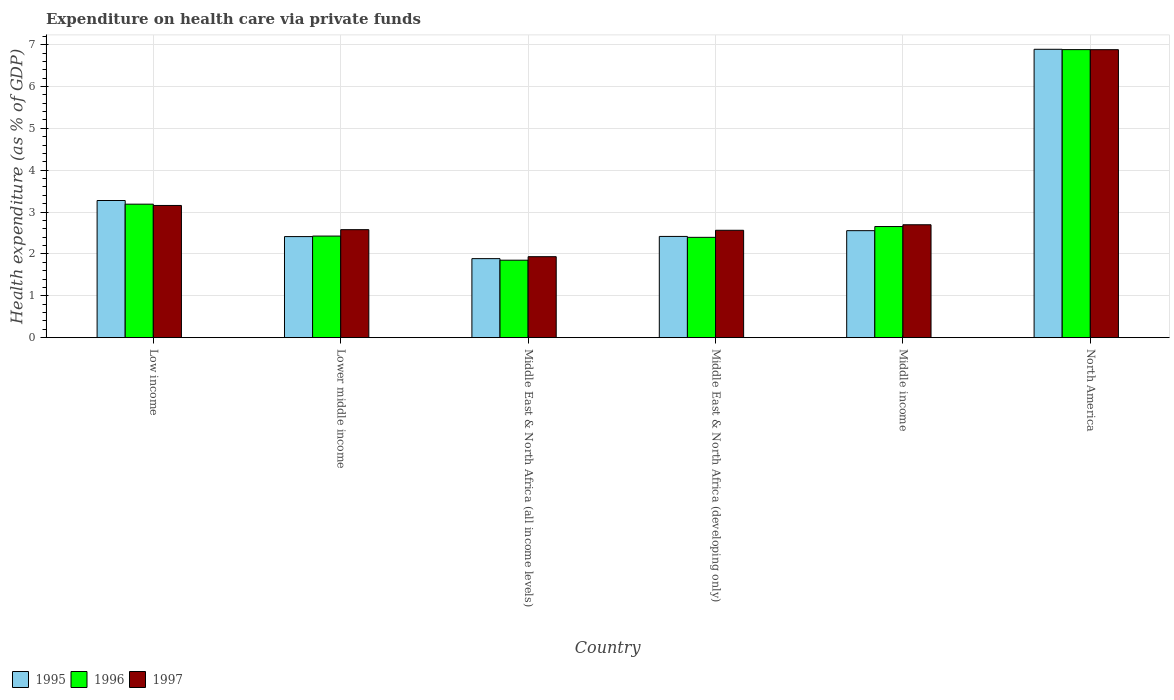Are the number of bars per tick equal to the number of legend labels?
Ensure brevity in your answer.  Yes. Are the number of bars on each tick of the X-axis equal?
Keep it short and to the point. Yes. How many bars are there on the 3rd tick from the right?
Your answer should be very brief. 3. What is the expenditure made on health care in 1996 in Middle East & North Africa (developing only)?
Ensure brevity in your answer.  2.4. Across all countries, what is the maximum expenditure made on health care in 1995?
Ensure brevity in your answer.  6.89. Across all countries, what is the minimum expenditure made on health care in 1996?
Provide a short and direct response. 1.85. In which country was the expenditure made on health care in 1997 maximum?
Provide a short and direct response. North America. In which country was the expenditure made on health care in 1995 minimum?
Your answer should be compact. Middle East & North Africa (all income levels). What is the total expenditure made on health care in 1996 in the graph?
Your response must be concise. 19.4. What is the difference between the expenditure made on health care in 1995 in Low income and that in Lower middle income?
Your answer should be very brief. 0.86. What is the difference between the expenditure made on health care in 1996 in North America and the expenditure made on health care in 1995 in Middle East & North Africa (all income levels)?
Ensure brevity in your answer.  4.99. What is the average expenditure made on health care in 1996 per country?
Your response must be concise. 3.23. What is the difference between the expenditure made on health care of/in 1996 and expenditure made on health care of/in 1995 in North America?
Your response must be concise. -0.01. What is the ratio of the expenditure made on health care in 1995 in Low income to that in North America?
Make the answer very short. 0.48. Is the expenditure made on health care in 1996 in Lower middle income less than that in North America?
Make the answer very short. Yes. What is the difference between the highest and the second highest expenditure made on health care in 1997?
Ensure brevity in your answer.  -0.46. What is the difference between the highest and the lowest expenditure made on health care in 1997?
Make the answer very short. 4.95. Is the sum of the expenditure made on health care in 1995 in Middle East & North Africa (all income levels) and Middle East & North Africa (developing only) greater than the maximum expenditure made on health care in 1996 across all countries?
Make the answer very short. No. What does the 2nd bar from the left in North America represents?
Your answer should be compact. 1996. What does the 3rd bar from the right in Middle income represents?
Make the answer very short. 1995. How many bars are there?
Offer a very short reply. 18. Are all the bars in the graph horizontal?
Offer a very short reply. No. How many countries are there in the graph?
Your answer should be very brief. 6. What is the difference between two consecutive major ticks on the Y-axis?
Your response must be concise. 1. What is the title of the graph?
Provide a short and direct response. Expenditure on health care via private funds. What is the label or title of the Y-axis?
Keep it short and to the point. Health expenditure (as % of GDP). What is the Health expenditure (as % of GDP) in 1995 in Low income?
Your answer should be compact. 3.28. What is the Health expenditure (as % of GDP) in 1996 in Low income?
Provide a short and direct response. 3.19. What is the Health expenditure (as % of GDP) of 1997 in Low income?
Provide a short and direct response. 3.16. What is the Health expenditure (as % of GDP) in 1995 in Lower middle income?
Keep it short and to the point. 2.41. What is the Health expenditure (as % of GDP) in 1996 in Lower middle income?
Offer a very short reply. 2.43. What is the Health expenditure (as % of GDP) of 1997 in Lower middle income?
Ensure brevity in your answer.  2.58. What is the Health expenditure (as % of GDP) in 1995 in Middle East & North Africa (all income levels)?
Offer a terse response. 1.89. What is the Health expenditure (as % of GDP) in 1996 in Middle East & North Africa (all income levels)?
Offer a very short reply. 1.85. What is the Health expenditure (as % of GDP) of 1997 in Middle East & North Africa (all income levels)?
Your answer should be compact. 1.93. What is the Health expenditure (as % of GDP) in 1995 in Middle East & North Africa (developing only)?
Provide a short and direct response. 2.42. What is the Health expenditure (as % of GDP) in 1996 in Middle East & North Africa (developing only)?
Make the answer very short. 2.4. What is the Health expenditure (as % of GDP) of 1997 in Middle East & North Africa (developing only)?
Your answer should be compact. 2.57. What is the Health expenditure (as % of GDP) in 1995 in Middle income?
Offer a very short reply. 2.56. What is the Health expenditure (as % of GDP) in 1996 in Middle income?
Your answer should be very brief. 2.65. What is the Health expenditure (as % of GDP) in 1997 in Middle income?
Your answer should be compact. 2.7. What is the Health expenditure (as % of GDP) in 1995 in North America?
Offer a very short reply. 6.89. What is the Health expenditure (as % of GDP) of 1996 in North America?
Your answer should be very brief. 6.88. What is the Health expenditure (as % of GDP) of 1997 in North America?
Ensure brevity in your answer.  6.88. Across all countries, what is the maximum Health expenditure (as % of GDP) of 1995?
Provide a short and direct response. 6.89. Across all countries, what is the maximum Health expenditure (as % of GDP) of 1996?
Offer a very short reply. 6.88. Across all countries, what is the maximum Health expenditure (as % of GDP) in 1997?
Ensure brevity in your answer.  6.88. Across all countries, what is the minimum Health expenditure (as % of GDP) in 1995?
Keep it short and to the point. 1.89. Across all countries, what is the minimum Health expenditure (as % of GDP) of 1996?
Make the answer very short. 1.85. Across all countries, what is the minimum Health expenditure (as % of GDP) in 1997?
Keep it short and to the point. 1.93. What is the total Health expenditure (as % of GDP) of 1995 in the graph?
Your answer should be compact. 19.44. What is the total Health expenditure (as % of GDP) of 1996 in the graph?
Your answer should be very brief. 19.4. What is the total Health expenditure (as % of GDP) of 1997 in the graph?
Make the answer very short. 19.81. What is the difference between the Health expenditure (as % of GDP) in 1995 in Low income and that in Lower middle income?
Your answer should be compact. 0.86. What is the difference between the Health expenditure (as % of GDP) of 1996 in Low income and that in Lower middle income?
Your answer should be very brief. 0.76. What is the difference between the Health expenditure (as % of GDP) in 1997 in Low income and that in Lower middle income?
Your response must be concise. 0.58. What is the difference between the Health expenditure (as % of GDP) in 1995 in Low income and that in Middle East & North Africa (all income levels)?
Your response must be concise. 1.39. What is the difference between the Health expenditure (as % of GDP) of 1996 in Low income and that in Middle East & North Africa (all income levels)?
Offer a terse response. 1.34. What is the difference between the Health expenditure (as % of GDP) of 1997 in Low income and that in Middle East & North Africa (all income levels)?
Your answer should be compact. 1.22. What is the difference between the Health expenditure (as % of GDP) of 1995 in Low income and that in Middle East & North Africa (developing only)?
Make the answer very short. 0.86. What is the difference between the Health expenditure (as % of GDP) in 1996 in Low income and that in Middle East & North Africa (developing only)?
Your answer should be very brief. 0.79. What is the difference between the Health expenditure (as % of GDP) of 1997 in Low income and that in Middle East & North Africa (developing only)?
Your answer should be compact. 0.59. What is the difference between the Health expenditure (as % of GDP) of 1995 in Low income and that in Middle income?
Give a very brief answer. 0.72. What is the difference between the Health expenditure (as % of GDP) in 1996 in Low income and that in Middle income?
Provide a short and direct response. 0.53. What is the difference between the Health expenditure (as % of GDP) in 1997 in Low income and that in Middle income?
Provide a short and direct response. 0.46. What is the difference between the Health expenditure (as % of GDP) in 1995 in Low income and that in North America?
Ensure brevity in your answer.  -3.61. What is the difference between the Health expenditure (as % of GDP) of 1996 in Low income and that in North America?
Keep it short and to the point. -3.69. What is the difference between the Health expenditure (as % of GDP) of 1997 in Low income and that in North America?
Your answer should be compact. -3.72. What is the difference between the Health expenditure (as % of GDP) of 1995 in Lower middle income and that in Middle East & North Africa (all income levels)?
Offer a terse response. 0.53. What is the difference between the Health expenditure (as % of GDP) in 1996 in Lower middle income and that in Middle East & North Africa (all income levels)?
Ensure brevity in your answer.  0.58. What is the difference between the Health expenditure (as % of GDP) in 1997 in Lower middle income and that in Middle East & North Africa (all income levels)?
Offer a terse response. 0.65. What is the difference between the Health expenditure (as % of GDP) in 1995 in Lower middle income and that in Middle East & North Africa (developing only)?
Give a very brief answer. -0. What is the difference between the Health expenditure (as % of GDP) of 1996 in Lower middle income and that in Middle East & North Africa (developing only)?
Ensure brevity in your answer.  0.03. What is the difference between the Health expenditure (as % of GDP) in 1997 in Lower middle income and that in Middle East & North Africa (developing only)?
Provide a short and direct response. 0.01. What is the difference between the Health expenditure (as % of GDP) of 1995 in Lower middle income and that in Middle income?
Ensure brevity in your answer.  -0.14. What is the difference between the Health expenditure (as % of GDP) in 1996 in Lower middle income and that in Middle income?
Your answer should be very brief. -0.23. What is the difference between the Health expenditure (as % of GDP) of 1997 in Lower middle income and that in Middle income?
Ensure brevity in your answer.  -0.12. What is the difference between the Health expenditure (as % of GDP) in 1995 in Lower middle income and that in North America?
Offer a terse response. -4.47. What is the difference between the Health expenditure (as % of GDP) of 1996 in Lower middle income and that in North America?
Offer a very short reply. -4.45. What is the difference between the Health expenditure (as % of GDP) of 1997 in Lower middle income and that in North America?
Make the answer very short. -4.3. What is the difference between the Health expenditure (as % of GDP) of 1995 in Middle East & North Africa (all income levels) and that in Middle East & North Africa (developing only)?
Keep it short and to the point. -0.53. What is the difference between the Health expenditure (as % of GDP) in 1996 in Middle East & North Africa (all income levels) and that in Middle East & North Africa (developing only)?
Your answer should be very brief. -0.55. What is the difference between the Health expenditure (as % of GDP) in 1997 in Middle East & North Africa (all income levels) and that in Middle East & North Africa (developing only)?
Offer a terse response. -0.63. What is the difference between the Health expenditure (as % of GDP) of 1995 in Middle East & North Africa (all income levels) and that in Middle income?
Keep it short and to the point. -0.67. What is the difference between the Health expenditure (as % of GDP) in 1996 in Middle East & North Africa (all income levels) and that in Middle income?
Keep it short and to the point. -0.8. What is the difference between the Health expenditure (as % of GDP) of 1997 in Middle East & North Africa (all income levels) and that in Middle income?
Your response must be concise. -0.76. What is the difference between the Health expenditure (as % of GDP) of 1995 in Middle East & North Africa (all income levels) and that in North America?
Your answer should be compact. -5. What is the difference between the Health expenditure (as % of GDP) in 1996 in Middle East & North Africa (all income levels) and that in North America?
Offer a terse response. -5.03. What is the difference between the Health expenditure (as % of GDP) of 1997 in Middle East & North Africa (all income levels) and that in North America?
Provide a short and direct response. -4.95. What is the difference between the Health expenditure (as % of GDP) in 1995 in Middle East & North Africa (developing only) and that in Middle income?
Offer a terse response. -0.14. What is the difference between the Health expenditure (as % of GDP) in 1996 in Middle East & North Africa (developing only) and that in Middle income?
Your answer should be compact. -0.26. What is the difference between the Health expenditure (as % of GDP) of 1997 in Middle East & North Africa (developing only) and that in Middle income?
Keep it short and to the point. -0.13. What is the difference between the Health expenditure (as % of GDP) of 1995 in Middle East & North Africa (developing only) and that in North America?
Provide a succinct answer. -4.47. What is the difference between the Health expenditure (as % of GDP) in 1996 in Middle East & North Africa (developing only) and that in North America?
Your answer should be compact. -4.48. What is the difference between the Health expenditure (as % of GDP) of 1997 in Middle East & North Africa (developing only) and that in North America?
Make the answer very short. -4.31. What is the difference between the Health expenditure (as % of GDP) of 1995 in Middle income and that in North America?
Your response must be concise. -4.33. What is the difference between the Health expenditure (as % of GDP) of 1996 in Middle income and that in North America?
Give a very brief answer. -4.23. What is the difference between the Health expenditure (as % of GDP) in 1997 in Middle income and that in North America?
Your response must be concise. -4.18. What is the difference between the Health expenditure (as % of GDP) of 1995 in Low income and the Health expenditure (as % of GDP) of 1996 in Lower middle income?
Offer a terse response. 0.85. What is the difference between the Health expenditure (as % of GDP) of 1995 in Low income and the Health expenditure (as % of GDP) of 1997 in Lower middle income?
Offer a terse response. 0.7. What is the difference between the Health expenditure (as % of GDP) in 1996 in Low income and the Health expenditure (as % of GDP) in 1997 in Lower middle income?
Your answer should be compact. 0.61. What is the difference between the Health expenditure (as % of GDP) in 1995 in Low income and the Health expenditure (as % of GDP) in 1996 in Middle East & North Africa (all income levels)?
Your answer should be very brief. 1.43. What is the difference between the Health expenditure (as % of GDP) of 1995 in Low income and the Health expenditure (as % of GDP) of 1997 in Middle East & North Africa (all income levels)?
Keep it short and to the point. 1.34. What is the difference between the Health expenditure (as % of GDP) in 1996 in Low income and the Health expenditure (as % of GDP) in 1997 in Middle East & North Africa (all income levels)?
Provide a succinct answer. 1.25. What is the difference between the Health expenditure (as % of GDP) of 1995 in Low income and the Health expenditure (as % of GDP) of 1996 in Middle East & North Africa (developing only)?
Provide a short and direct response. 0.88. What is the difference between the Health expenditure (as % of GDP) of 1995 in Low income and the Health expenditure (as % of GDP) of 1997 in Middle East & North Africa (developing only)?
Your answer should be compact. 0.71. What is the difference between the Health expenditure (as % of GDP) in 1996 in Low income and the Health expenditure (as % of GDP) in 1997 in Middle East & North Africa (developing only)?
Your answer should be compact. 0.62. What is the difference between the Health expenditure (as % of GDP) in 1995 in Low income and the Health expenditure (as % of GDP) in 1996 in Middle income?
Your response must be concise. 0.62. What is the difference between the Health expenditure (as % of GDP) of 1995 in Low income and the Health expenditure (as % of GDP) of 1997 in Middle income?
Offer a very short reply. 0.58. What is the difference between the Health expenditure (as % of GDP) of 1996 in Low income and the Health expenditure (as % of GDP) of 1997 in Middle income?
Provide a short and direct response. 0.49. What is the difference between the Health expenditure (as % of GDP) in 1995 in Low income and the Health expenditure (as % of GDP) in 1996 in North America?
Ensure brevity in your answer.  -3.6. What is the difference between the Health expenditure (as % of GDP) in 1995 in Low income and the Health expenditure (as % of GDP) in 1997 in North America?
Your answer should be very brief. -3.6. What is the difference between the Health expenditure (as % of GDP) of 1996 in Low income and the Health expenditure (as % of GDP) of 1997 in North America?
Ensure brevity in your answer.  -3.69. What is the difference between the Health expenditure (as % of GDP) in 1995 in Lower middle income and the Health expenditure (as % of GDP) in 1996 in Middle East & North Africa (all income levels)?
Ensure brevity in your answer.  0.56. What is the difference between the Health expenditure (as % of GDP) in 1995 in Lower middle income and the Health expenditure (as % of GDP) in 1997 in Middle East & North Africa (all income levels)?
Offer a terse response. 0.48. What is the difference between the Health expenditure (as % of GDP) of 1996 in Lower middle income and the Health expenditure (as % of GDP) of 1997 in Middle East & North Africa (all income levels)?
Provide a short and direct response. 0.49. What is the difference between the Health expenditure (as % of GDP) of 1995 in Lower middle income and the Health expenditure (as % of GDP) of 1996 in Middle East & North Africa (developing only)?
Offer a terse response. 0.02. What is the difference between the Health expenditure (as % of GDP) of 1995 in Lower middle income and the Health expenditure (as % of GDP) of 1997 in Middle East & North Africa (developing only)?
Your answer should be very brief. -0.15. What is the difference between the Health expenditure (as % of GDP) in 1996 in Lower middle income and the Health expenditure (as % of GDP) in 1997 in Middle East & North Africa (developing only)?
Your answer should be compact. -0.14. What is the difference between the Health expenditure (as % of GDP) of 1995 in Lower middle income and the Health expenditure (as % of GDP) of 1996 in Middle income?
Your answer should be very brief. -0.24. What is the difference between the Health expenditure (as % of GDP) of 1995 in Lower middle income and the Health expenditure (as % of GDP) of 1997 in Middle income?
Your answer should be very brief. -0.28. What is the difference between the Health expenditure (as % of GDP) in 1996 in Lower middle income and the Health expenditure (as % of GDP) in 1997 in Middle income?
Provide a short and direct response. -0.27. What is the difference between the Health expenditure (as % of GDP) in 1995 in Lower middle income and the Health expenditure (as % of GDP) in 1996 in North America?
Make the answer very short. -4.47. What is the difference between the Health expenditure (as % of GDP) in 1995 in Lower middle income and the Health expenditure (as % of GDP) in 1997 in North America?
Give a very brief answer. -4.47. What is the difference between the Health expenditure (as % of GDP) of 1996 in Lower middle income and the Health expenditure (as % of GDP) of 1997 in North America?
Provide a succinct answer. -4.45. What is the difference between the Health expenditure (as % of GDP) of 1995 in Middle East & North Africa (all income levels) and the Health expenditure (as % of GDP) of 1996 in Middle East & North Africa (developing only)?
Your response must be concise. -0.51. What is the difference between the Health expenditure (as % of GDP) in 1995 in Middle East & North Africa (all income levels) and the Health expenditure (as % of GDP) in 1997 in Middle East & North Africa (developing only)?
Provide a succinct answer. -0.68. What is the difference between the Health expenditure (as % of GDP) of 1996 in Middle East & North Africa (all income levels) and the Health expenditure (as % of GDP) of 1997 in Middle East & North Africa (developing only)?
Provide a short and direct response. -0.71. What is the difference between the Health expenditure (as % of GDP) in 1995 in Middle East & North Africa (all income levels) and the Health expenditure (as % of GDP) in 1996 in Middle income?
Keep it short and to the point. -0.77. What is the difference between the Health expenditure (as % of GDP) of 1995 in Middle East & North Africa (all income levels) and the Health expenditure (as % of GDP) of 1997 in Middle income?
Make the answer very short. -0.81. What is the difference between the Health expenditure (as % of GDP) in 1996 in Middle East & North Africa (all income levels) and the Health expenditure (as % of GDP) in 1997 in Middle income?
Offer a terse response. -0.85. What is the difference between the Health expenditure (as % of GDP) of 1995 in Middle East & North Africa (all income levels) and the Health expenditure (as % of GDP) of 1996 in North America?
Your response must be concise. -4.99. What is the difference between the Health expenditure (as % of GDP) of 1995 in Middle East & North Africa (all income levels) and the Health expenditure (as % of GDP) of 1997 in North America?
Your answer should be very brief. -4.99. What is the difference between the Health expenditure (as % of GDP) of 1996 in Middle East & North Africa (all income levels) and the Health expenditure (as % of GDP) of 1997 in North America?
Your response must be concise. -5.03. What is the difference between the Health expenditure (as % of GDP) of 1995 in Middle East & North Africa (developing only) and the Health expenditure (as % of GDP) of 1996 in Middle income?
Offer a very short reply. -0.24. What is the difference between the Health expenditure (as % of GDP) in 1995 in Middle East & North Africa (developing only) and the Health expenditure (as % of GDP) in 1997 in Middle income?
Your answer should be compact. -0.28. What is the difference between the Health expenditure (as % of GDP) in 1996 in Middle East & North Africa (developing only) and the Health expenditure (as % of GDP) in 1997 in Middle income?
Your answer should be compact. -0.3. What is the difference between the Health expenditure (as % of GDP) in 1995 in Middle East & North Africa (developing only) and the Health expenditure (as % of GDP) in 1996 in North America?
Your answer should be very brief. -4.46. What is the difference between the Health expenditure (as % of GDP) in 1995 in Middle East & North Africa (developing only) and the Health expenditure (as % of GDP) in 1997 in North America?
Offer a very short reply. -4.46. What is the difference between the Health expenditure (as % of GDP) in 1996 in Middle East & North Africa (developing only) and the Health expenditure (as % of GDP) in 1997 in North America?
Provide a short and direct response. -4.48. What is the difference between the Health expenditure (as % of GDP) of 1995 in Middle income and the Health expenditure (as % of GDP) of 1996 in North America?
Give a very brief answer. -4.33. What is the difference between the Health expenditure (as % of GDP) of 1995 in Middle income and the Health expenditure (as % of GDP) of 1997 in North America?
Make the answer very short. -4.32. What is the difference between the Health expenditure (as % of GDP) of 1996 in Middle income and the Health expenditure (as % of GDP) of 1997 in North America?
Provide a short and direct response. -4.23. What is the average Health expenditure (as % of GDP) of 1995 per country?
Give a very brief answer. 3.24. What is the average Health expenditure (as % of GDP) of 1996 per country?
Ensure brevity in your answer.  3.23. What is the average Health expenditure (as % of GDP) of 1997 per country?
Ensure brevity in your answer.  3.3. What is the difference between the Health expenditure (as % of GDP) in 1995 and Health expenditure (as % of GDP) in 1996 in Low income?
Ensure brevity in your answer.  0.09. What is the difference between the Health expenditure (as % of GDP) of 1995 and Health expenditure (as % of GDP) of 1997 in Low income?
Your response must be concise. 0.12. What is the difference between the Health expenditure (as % of GDP) in 1996 and Health expenditure (as % of GDP) in 1997 in Low income?
Keep it short and to the point. 0.03. What is the difference between the Health expenditure (as % of GDP) of 1995 and Health expenditure (as % of GDP) of 1996 in Lower middle income?
Give a very brief answer. -0.01. What is the difference between the Health expenditure (as % of GDP) in 1995 and Health expenditure (as % of GDP) in 1997 in Lower middle income?
Your response must be concise. -0.17. What is the difference between the Health expenditure (as % of GDP) in 1996 and Health expenditure (as % of GDP) in 1997 in Lower middle income?
Provide a short and direct response. -0.15. What is the difference between the Health expenditure (as % of GDP) of 1995 and Health expenditure (as % of GDP) of 1996 in Middle East & North Africa (all income levels)?
Provide a succinct answer. 0.04. What is the difference between the Health expenditure (as % of GDP) in 1995 and Health expenditure (as % of GDP) in 1997 in Middle East & North Africa (all income levels)?
Make the answer very short. -0.05. What is the difference between the Health expenditure (as % of GDP) of 1996 and Health expenditure (as % of GDP) of 1997 in Middle East & North Africa (all income levels)?
Your answer should be compact. -0.08. What is the difference between the Health expenditure (as % of GDP) in 1995 and Health expenditure (as % of GDP) in 1996 in Middle East & North Africa (developing only)?
Offer a very short reply. 0.02. What is the difference between the Health expenditure (as % of GDP) in 1995 and Health expenditure (as % of GDP) in 1997 in Middle East & North Africa (developing only)?
Provide a succinct answer. -0.15. What is the difference between the Health expenditure (as % of GDP) in 1996 and Health expenditure (as % of GDP) in 1997 in Middle East & North Africa (developing only)?
Your response must be concise. -0.17. What is the difference between the Health expenditure (as % of GDP) in 1995 and Health expenditure (as % of GDP) in 1996 in Middle income?
Offer a terse response. -0.1. What is the difference between the Health expenditure (as % of GDP) of 1995 and Health expenditure (as % of GDP) of 1997 in Middle income?
Give a very brief answer. -0.14. What is the difference between the Health expenditure (as % of GDP) in 1996 and Health expenditure (as % of GDP) in 1997 in Middle income?
Offer a very short reply. -0.04. What is the difference between the Health expenditure (as % of GDP) of 1995 and Health expenditure (as % of GDP) of 1996 in North America?
Provide a succinct answer. 0.01. What is the difference between the Health expenditure (as % of GDP) in 1995 and Health expenditure (as % of GDP) in 1997 in North America?
Your response must be concise. 0.01. What is the difference between the Health expenditure (as % of GDP) of 1996 and Health expenditure (as % of GDP) of 1997 in North America?
Offer a very short reply. 0. What is the ratio of the Health expenditure (as % of GDP) of 1995 in Low income to that in Lower middle income?
Give a very brief answer. 1.36. What is the ratio of the Health expenditure (as % of GDP) of 1996 in Low income to that in Lower middle income?
Your answer should be compact. 1.31. What is the ratio of the Health expenditure (as % of GDP) in 1997 in Low income to that in Lower middle income?
Your answer should be very brief. 1.22. What is the ratio of the Health expenditure (as % of GDP) of 1995 in Low income to that in Middle East & North Africa (all income levels)?
Your response must be concise. 1.74. What is the ratio of the Health expenditure (as % of GDP) of 1996 in Low income to that in Middle East & North Africa (all income levels)?
Ensure brevity in your answer.  1.72. What is the ratio of the Health expenditure (as % of GDP) of 1997 in Low income to that in Middle East & North Africa (all income levels)?
Give a very brief answer. 1.63. What is the ratio of the Health expenditure (as % of GDP) in 1995 in Low income to that in Middle East & North Africa (developing only)?
Give a very brief answer. 1.35. What is the ratio of the Health expenditure (as % of GDP) of 1996 in Low income to that in Middle East & North Africa (developing only)?
Give a very brief answer. 1.33. What is the ratio of the Health expenditure (as % of GDP) of 1997 in Low income to that in Middle East & North Africa (developing only)?
Keep it short and to the point. 1.23. What is the ratio of the Health expenditure (as % of GDP) in 1995 in Low income to that in Middle income?
Provide a succinct answer. 1.28. What is the ratio of the Health expenditure (as % of GDP) of 1996 in Low income to that in Middle income?
Your response must be concise. 1.2. What is the ratio of the Health expenditure (as % of GDP) in 1997 in Low income to that in Middle income?
Give a very brief answer. 1.17. What is the ratio of the Health expenditure (as % of GDP) in 1995 in Low income to that in North America?
Give a very brief answer. 0.48. What is the ratio of the Health expenditure (as % of GDP) in 1996 in Low income to that in North America?
Provide a short and direct response. 0.46. What is the ratio of the Health expenditure (as % of GDP) in 1997 in Low income to that in North America?
Your answer should be compact. 0.46. What is the ratio of the Health expenditure (as % of GDP) in 1995 in Lower middle income to that in Middle East & North Africa (all income levels)?
Provide a succinct answer. 1.28. What is the ratio of the Health expenditure (as % of GDP) of 1996 in Lower middle income to that in Middle East & North Africa (all income levels)?
Your answer should be compact. 1.31. What is the ratio of the Health expenditure (as % of GDP) of 1997 in Lower middle income to that in Middle East & North Africa (all income levels)?
Offer a very short reply. 1.33. What is the ratio of the Health expenditure (as % of GDP) in 1996 in Lower middle income to that in Middle East & North Africa (developing only)?
Make the answer very short. 1.01. What is the ratio of the Health expenditure (as % of GDP) in 1997 in Lower middle income to that in Middle East & North Africa (developing only)?
Provide a short and direct response. 1.01. What is the ratio of the Health expenditure (as % of GDP) of 1995 in Lower middle income to that in Middle income?
Your answer should be very brief. 0.94. What is the ratio of the Health expenditure (as % of GDP) of 1996 in Lower middle income to that in Middle income?
Your response must be concise. 0.91. What is the ratio of the Health expenditure (as % of GDP) in 1997 in Lower middle income to that in Middle income?
Provide a succinct answer. 0.96. What is the ratio of the Health expenditure (as % of GDP) of 1995 in Lower middle income to that in North America?
Your response must be concise. 0.35. What is the ratio of the Health expenditure (as % of GDP) in 1996 in Lower middle income to that in North America?
Your answer should be very brief. 0.35. What is the ratio of the Health expenditure (as % of GDP) of 1995 in Middle East & North Africa (all income levels) to that in Middle East & North Africa (developing only)?
Provide a short and direct response. 0.78. What is the ratio of the Health expenditure (as % of GDP) of 1996 in Middle East & North Africa (all income levels) to that in Middle East & North Africa (developing only)?
Your response must be concise. 0.77. What is the ratio of the Health expenditure (as % of GDP) in 1997 in Middle East & North Africa (all income levels) to that in Middle East & North Africa (developing only)?
Provide a short and direct response. 0.75. What is the ratio of the Health expenditure (as % of GDP) of 1995 in Middle East & North Africa (all income levels) to that in Middle income?
Keep it short and to the point. 0.74. What is the ratio of the Health expenditure (as % of GDP) in 1996 in Middle East & North Africa (all income levels) to that in Middle income?
Your response must be concise. 0.7. What is the ratio of the Health expenditure (as % of GDP) of 1997 in Middle East & North Africa (all income levels) to that in Middle income?
Ensure brevity in your answer.  0.72. What is the ratio of the Health expenditure (as % of GDP) in 1995 in Middle East & North Africa (all income levels) to that in North America?
Offer a very short reply. 0.27. What is the ratio of the Health expenditure (as % of GDP) in 1996 in Middle East & North Africa (all income levels) to that in North America?
Keep it short and to the point. 0.27. What is the ratio of the Health expenditure (as % of GDP) of 1997 in Middle East & North Africa (all income levels) to that in North America?
Give a very brief answer. 0.28. What is the ratio of the Health expenditure (as % of GDP) in 1995 in Middle East & North Africa (developing only) to that in Middle income?
Provide a short and direct response. 0.95. What is the ratio of the Health expenditure (as % of GDP) in 1996 in Middle East & North Africa (developing only) to that in Middle income?
Offer a very short reply. 0.9. What is the ratio of the Health expenditure (as % of GDP) of 1997 in Middle East & North Africa (developing only) to that in Middle income?
Keep it short and to the point. 0.95. What is the ratio of the Health expenditure (as % of GDP) in 1995 in Middle East & North Africa (developing only) to that in North America?
Make the answer very short. 0.35. What is the ratio of the Health expenditure (as % of GDP) of 1996 in Middle East & North Africa (developing only) to that in North America?
Your answer should be compact. 0.35. What is the ratio of the Health expenditure (as % of GDP) in 1997 in Middle East & North Africa (developing only) to that in North America?
Ensure brevity in your answer.  0.37. What is the ratio of the Health expenditure (as % of GDP) in 1995 in Middle income to that in North America?
Offer a terse response. 0.37. What is the ratio of the Health expenditure (as % of GDP) in 1996 in Middle income to that in North America?
Offer a very short reply. 0.39. What is the ratio of the Health expenditure (as % of GDP) in 1997 in Middle income to that in North America?
Your answer should be compact. 0.39. What is the difference between the highest and the second highest Health expenditure (as % of GDP) of 1995?
Provide a short and direct response. 3.61. What is the difference between the highest and the second highest Health expenditure (as % of GDP) in 1996?
Offer a very short reply. 3.69. What is the difference between the highest and the second highest Health expenditure (as % of GDP) in 1997?
Your answer should be very brief. 3.72. What is the difference between the highest and the lowest Health expenditure (as % of GDP) of 1995?
Keep it short and to the point. 5. What is the difference between the highest and the lowest Health expenditure (as % of GDP) of 1996?
Your answer should be compact. 5.03. What is the difference between the highest and the lowest Health expenditure (as % of GDP) in 1997?
Provide a succinct answer. 4.95. 